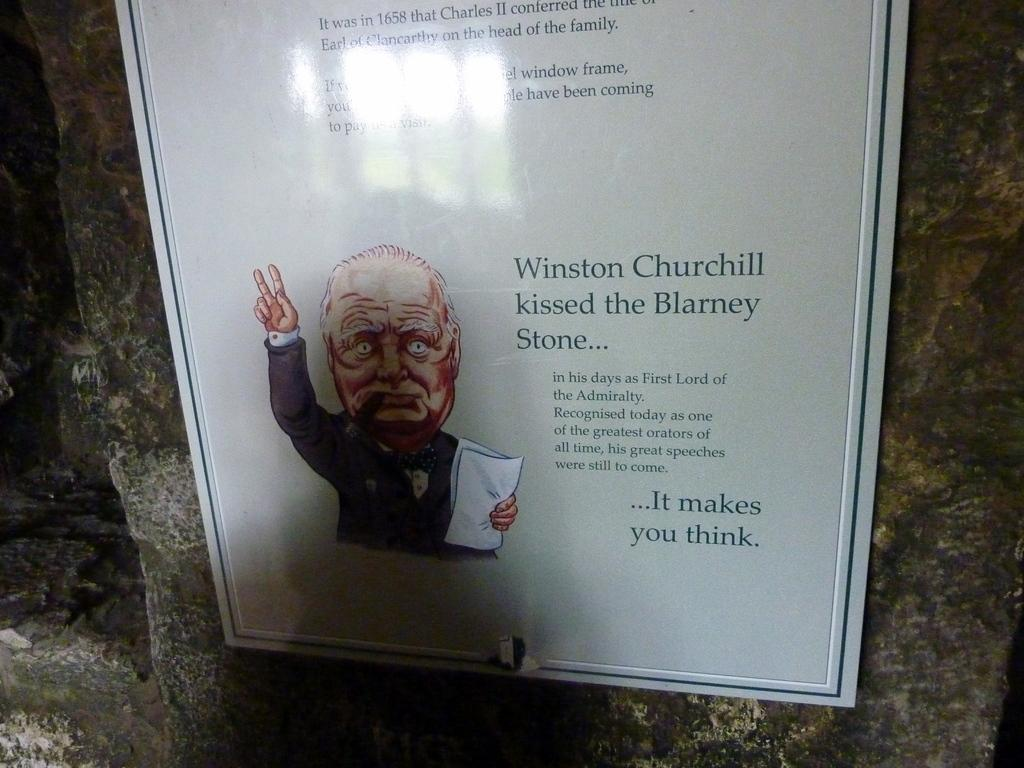What is on the wall in the image? There is a board on the wall in the image. What is depicted on the board? The board contains a picture of a person. Are there any words or phrases on the board? Yes, there is text written on the board. Can you see a collar on the person in the picture? There is no collar visible on the person in the picture, as the image only shows a picture of a person on the board. 